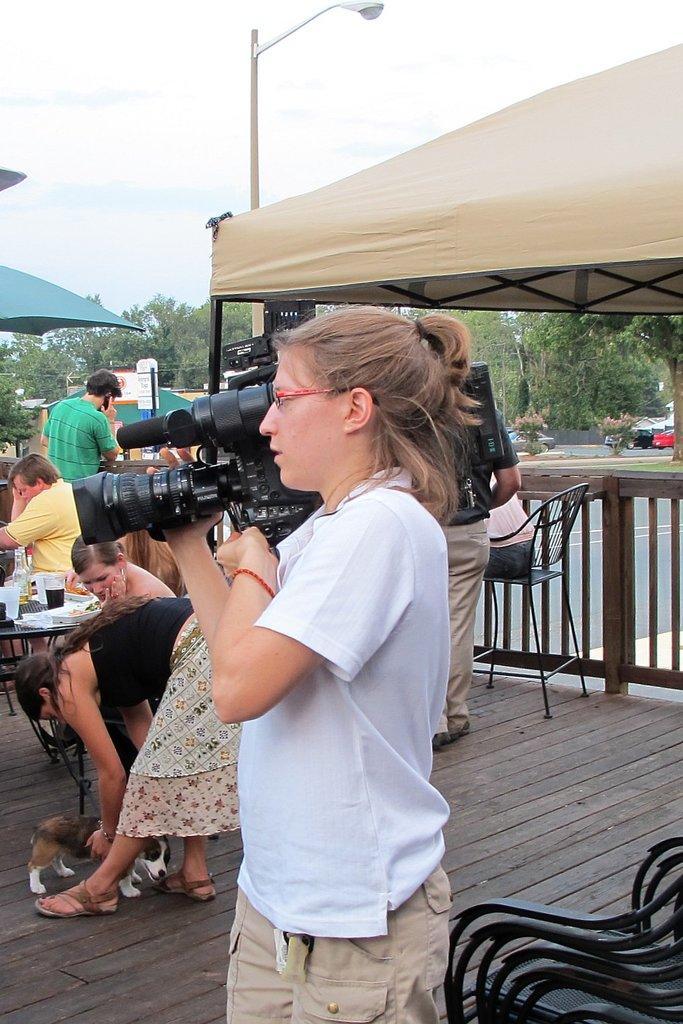How would you summarize this image in a sentence or two? In this picture I can see a woman holding camera and standing, side I can see some people are standing and some people are sitting on the chairs in front of the table, on which I can see so many objects are placed, background of the image I can see some tents, vehicles on the road and some trees. 